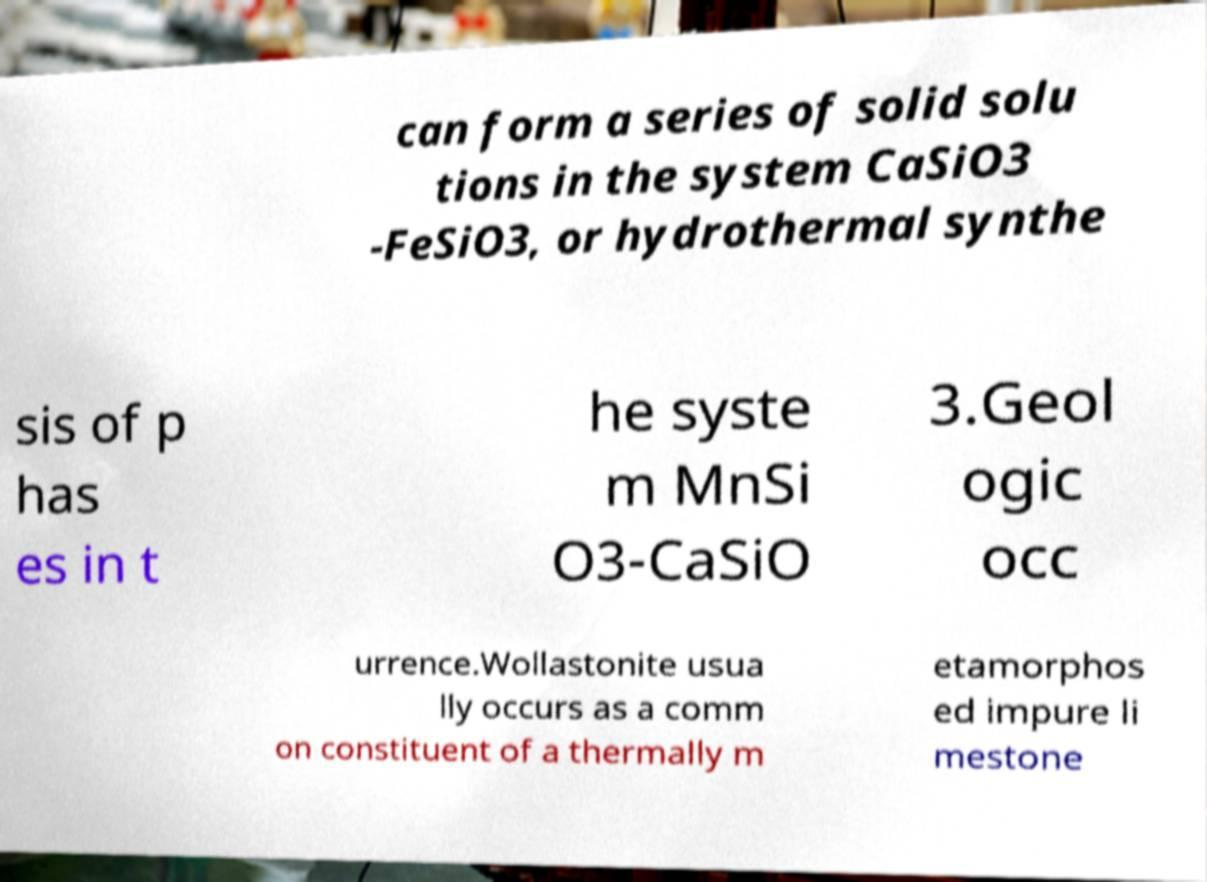Could you extract and type out the text from this image? can form a series of solid solu tions in the system CaSiO3 -FeSiO3, or hydrothermal synthe sis of p has es in t he syste m MnSi O3-CaSiO 3.Geol ogic occ urrence.Wollastonite usua lly occurs as a comm on constituent of a thermally m etamorphos ed impure li mestone 